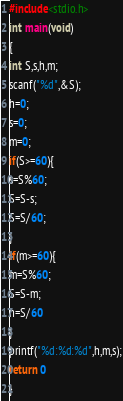<code> <loc_0><loc_0><loc_500><loc_500><_C_>#include<stdio.h>
int main(void)
{
int S,s,h,m;
scanf("%d",&S);
h=0;
s=0;
m=0;
if(S>=60){
s=S%60;
S=S-s;
S=S/60;
}
if(m>=60){
m=S%60;
S=S-m;
h=S/60
}
printf("%d:%d:%d",h,m,s);
return 0
}</code> 